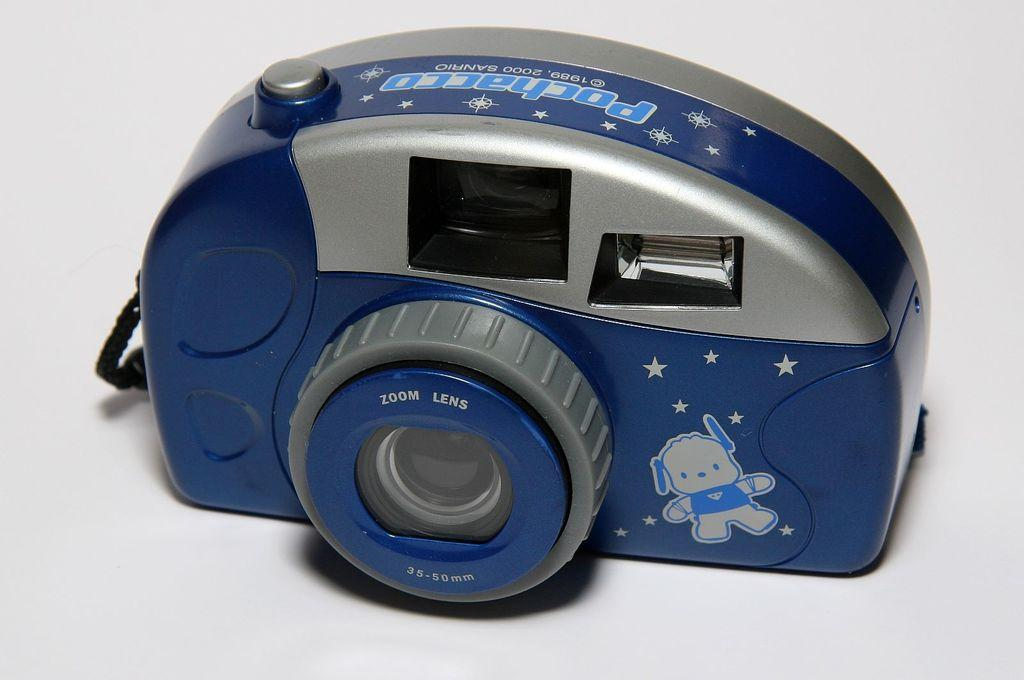What object is the main subject of the image? There is a camera in the image. What colors can be seen on the camera? The camera is blue and silver in color. What feature of the camera is visible in the image? The camera has lenses. What is the color of the background in the image? The background of the image appears white. What type of produce is being displayed on the camera in the image? There is no produce present in the image; the main subject is a camera. Is there a scarf wrapped around the camera in the image? No, there is no scarf present in the image. 